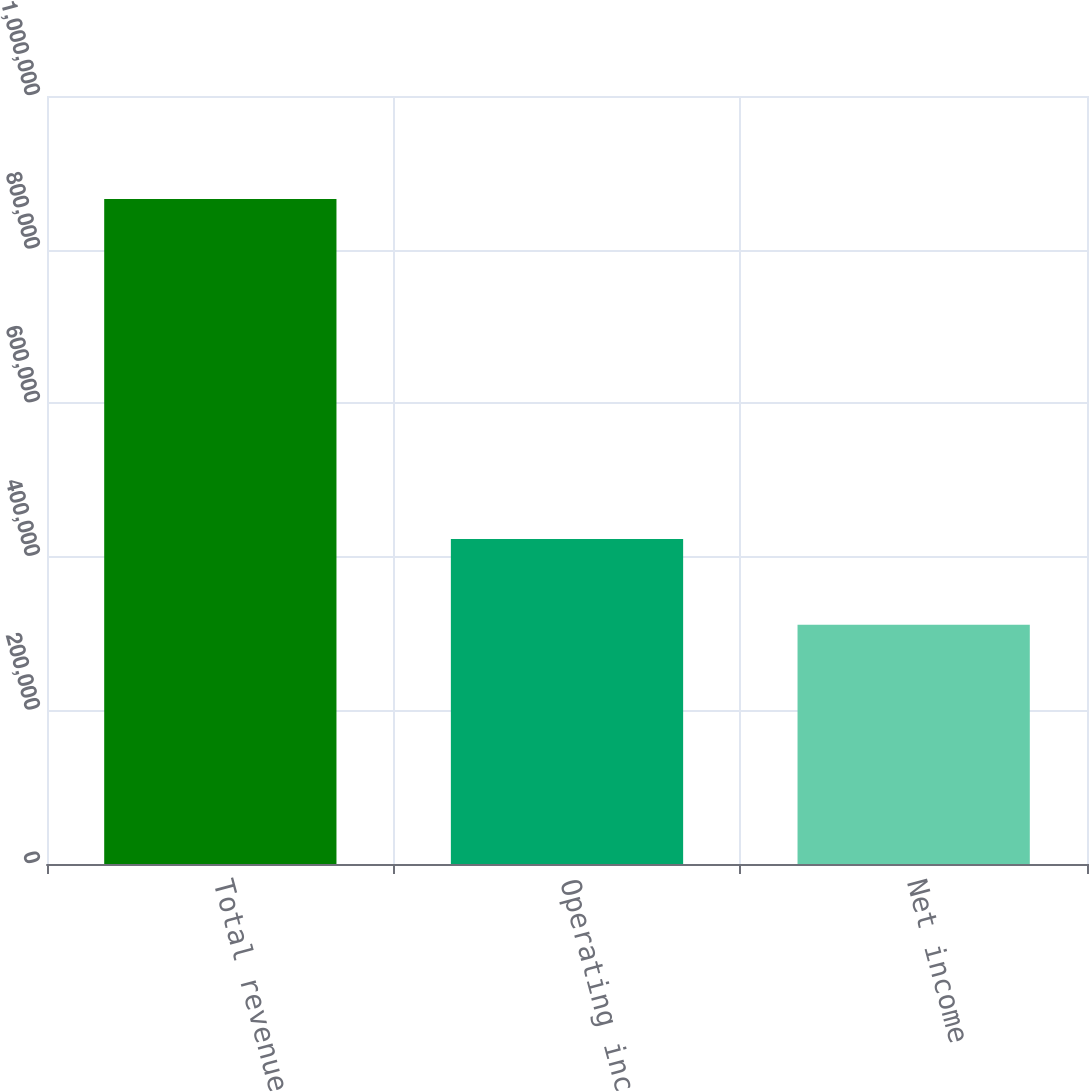Convert chart to OTSL. <chart><loc_0><loc_0><loc_500><loc_500><bar_chart><fcel>Total revenue<fcel>Operating income<fcel>Net income<nl><fcel>865892<fcel>423095<fcel>311524<nl></chart> 